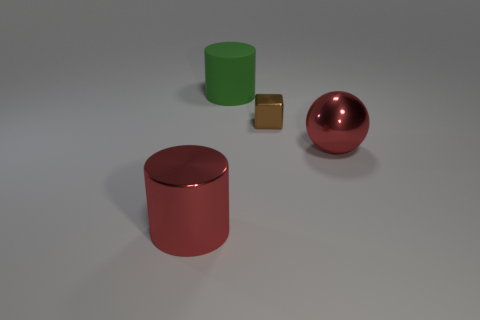Add 2 green rubber spheres. How many objects exist? 6 Subtract all cubes. How many objects are left? 3 Subtract 0 blue spheres. How many objects are left? 4 Subtract all small blocks. Subtract all large green cylinders. How many objects are left? 2 Add 1 big red metallic things. How many big red metallic things are left? 3 Add 4 tiny yellow cylinders. How many tiny yellow cylinders exist? 4 